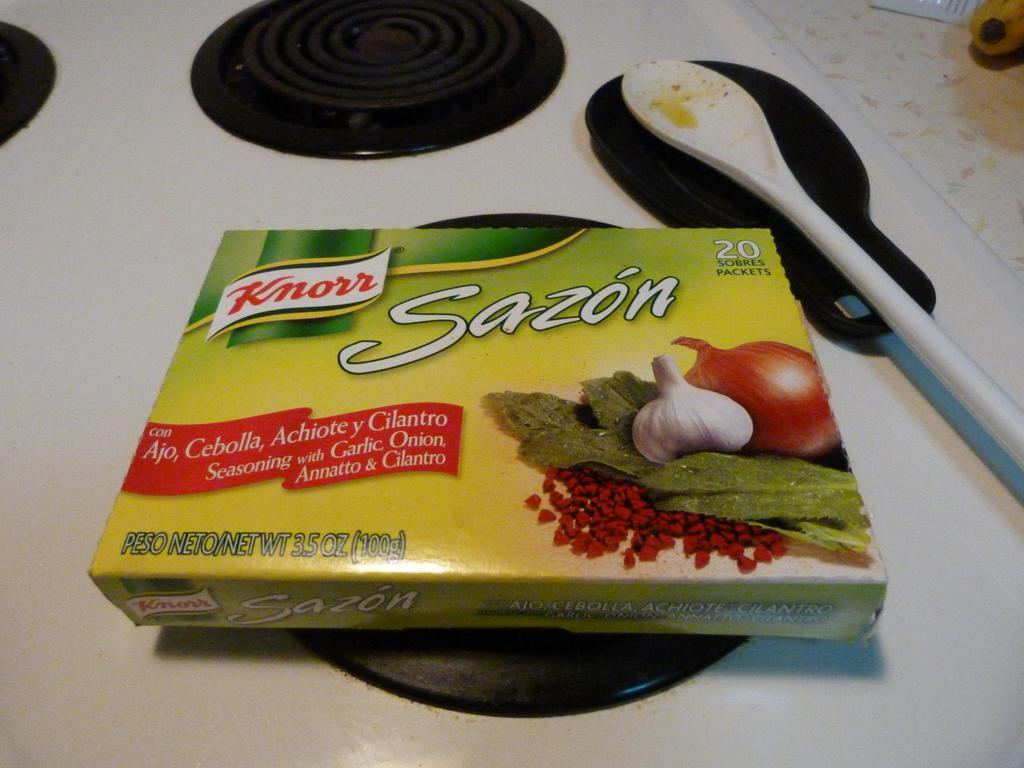What type of food product is on the table in the image? There is a Knorr soup box on the table. What utensil is present on the table? There is a spoon on the table. What is used for serving food on the table? There is a plate on the table. How many masks are being used to measure the soup in the image? There are no masks present in the image, nor is there any indication of measuring soup. 